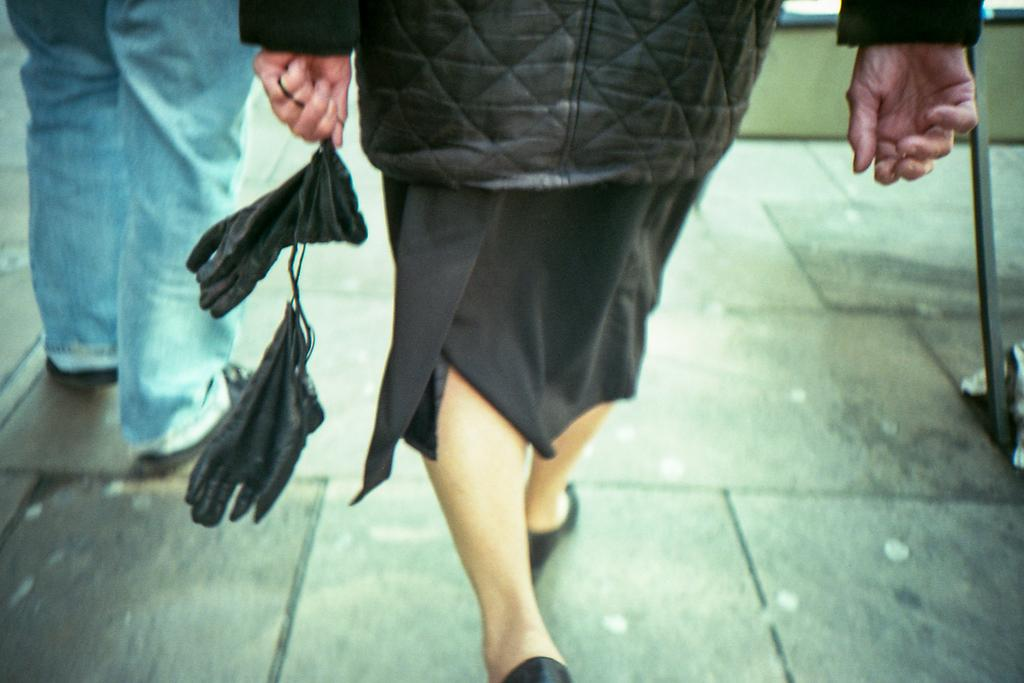What is the main action being performed by the person in the image? The person in the image is walking. What surface is the person walking on? The person is walking on the floor. What is the person holding in her hand? The person is holding black color gloves in her hand. Can you describe the position of the second person in the image? The second person is standing in the image, and they are also standing on the floor. What type of cherries can be seen on the tail of the person walking in the image? There are no cherries or tails present on the person walking in the image. 